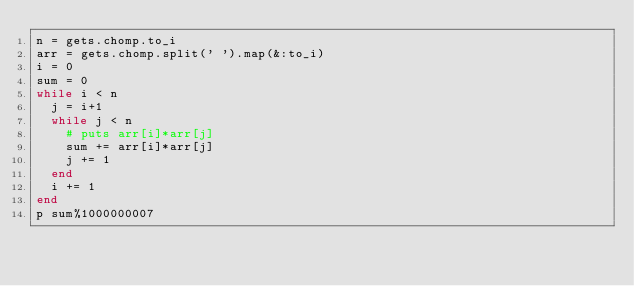<code> <loc_0><loc_0><loc_500><loc_500><_Ruby_>n = gets.chomp.to_i
arr = gets.chomp.split(' ').map(&:to_i)
i = 0
sum = 0
while i < n
  j = i+1
  while j < n
    # puts arr[i]*arr[j]
    sum += arr[i]*arr[j]
    j += 1
  end
  i += 1
end
p sum%1000000007</code> 